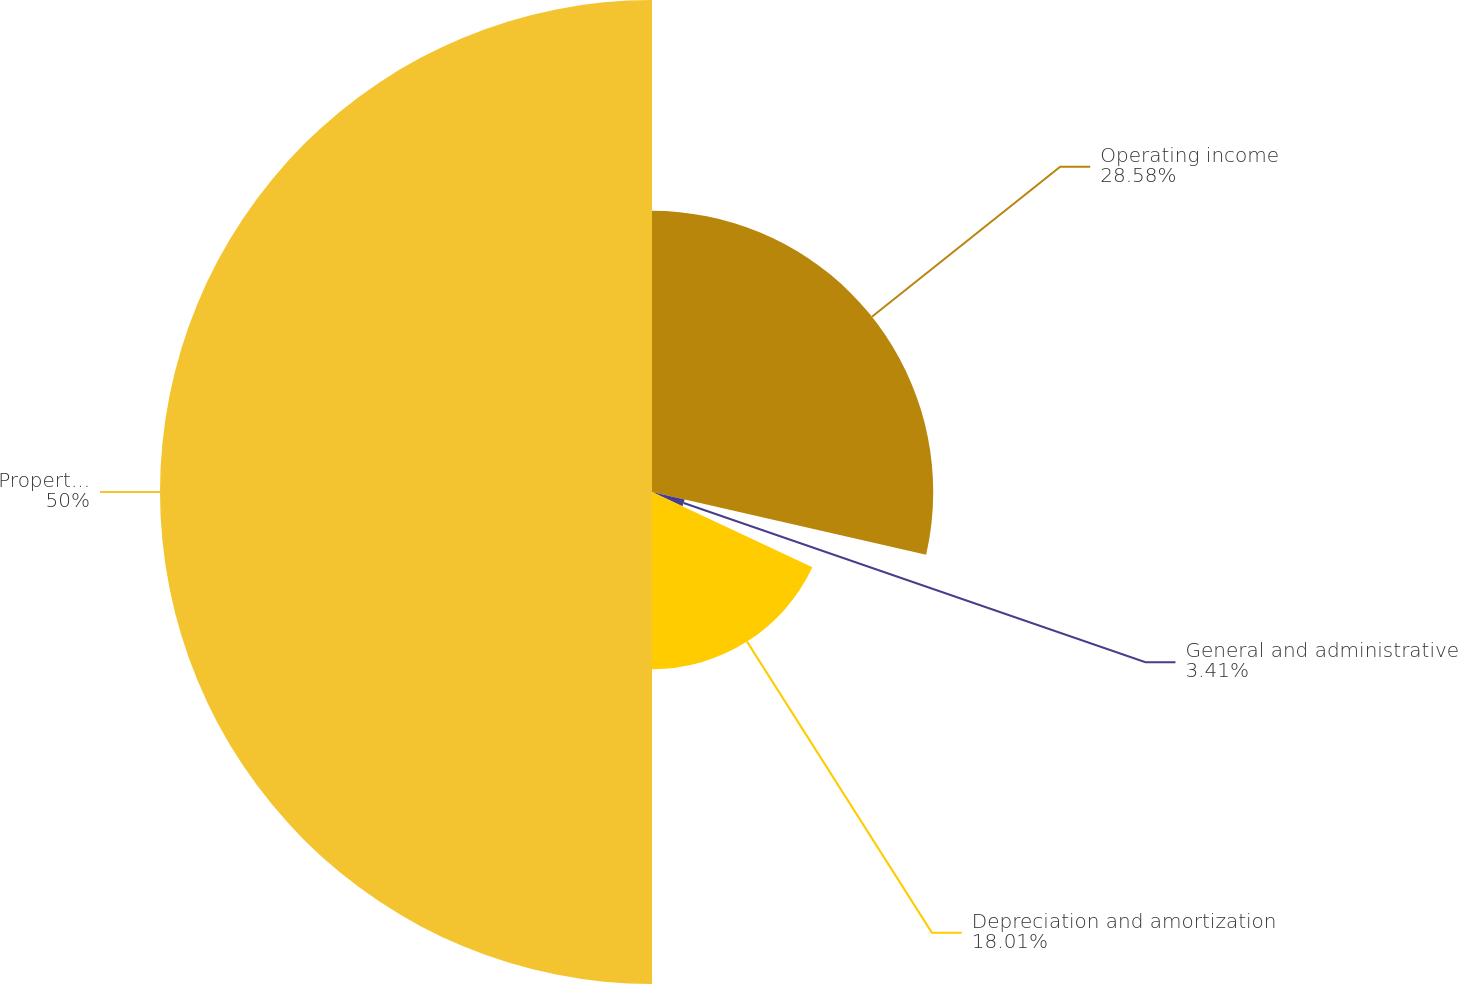Convert chart to OTSL. <chart><loc_0><loc_0><loc_500><loc_500><pie_chart><fcel>Operating income<fcel>General and administrative<fcel>Depreciation and amortization<fcel>Property operating income<nl><fcel>28.58%<fcel>3.41%<fcel>18.01%<fcel>50.0%<nl></chart> 